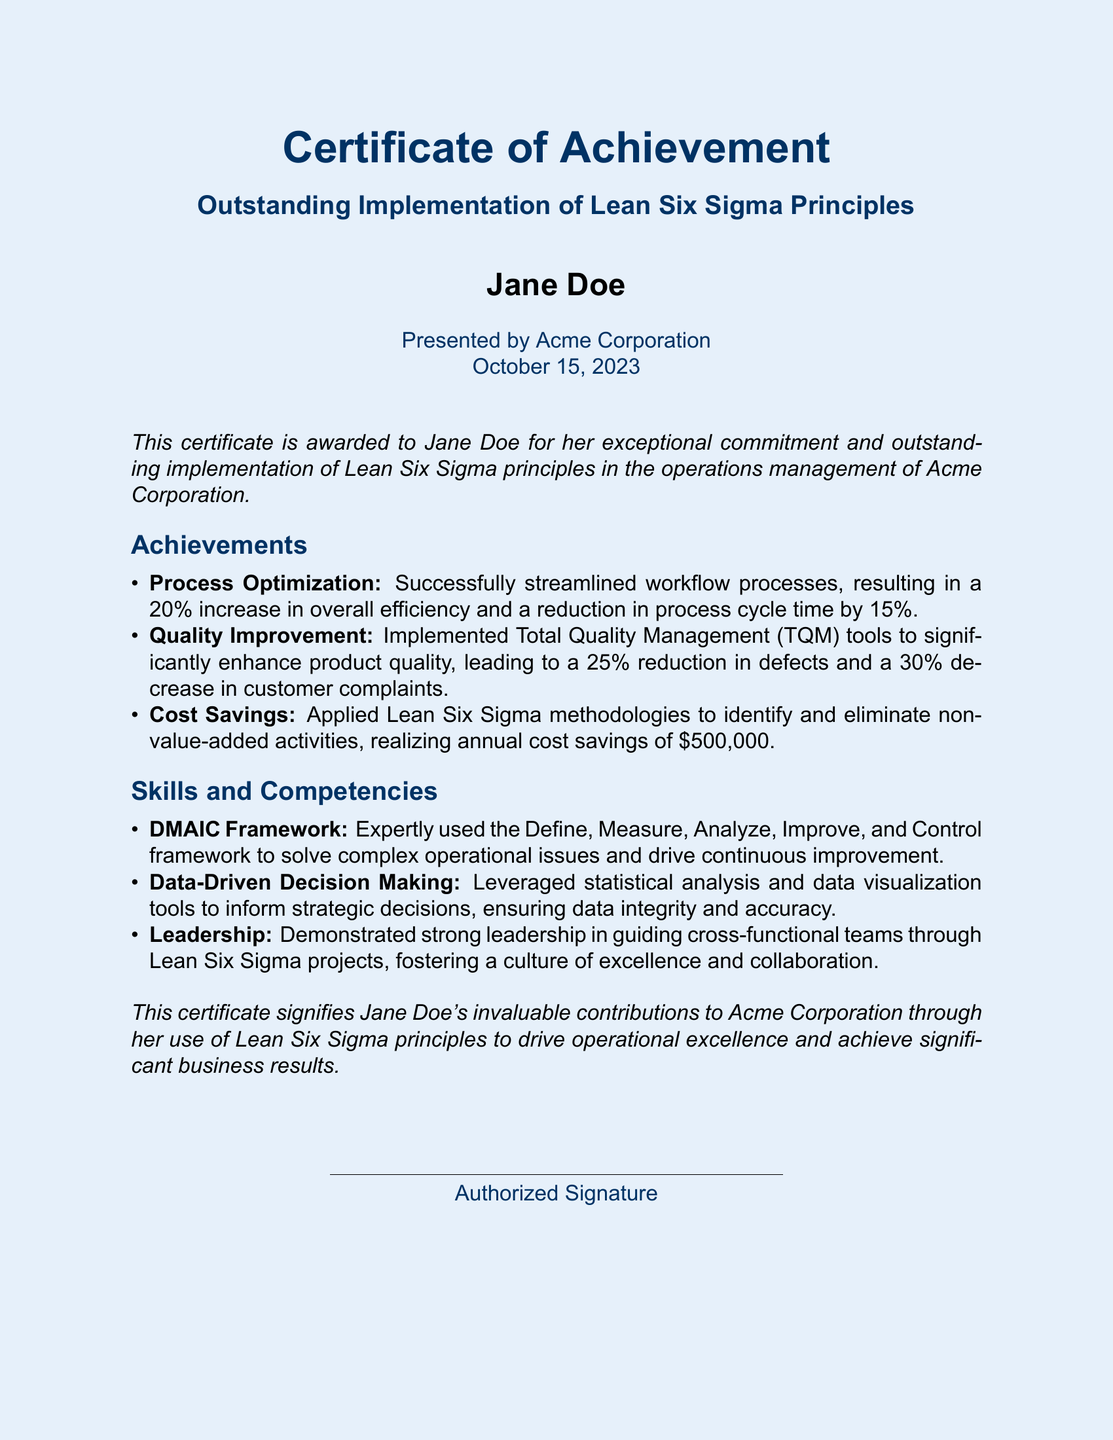What is the title of the certificate? The title of the certificate is prominently displayed in the document as "Outstanding Implementation of Lean Six Sigma Principles."
Answer: Outstanding Implementation of Lean Six Sigma Principles Who is the recipient of the certificate? The recipient's name, as noted on the certificate, is "Jane Doe."
Answer: Jane Doe What date was the certificate awarded? The date of the certificate is mentioned at the bottom, which is "October 15, 2023."
Answer: October 15, 2023 What percentage increase in efficiency was achieved? The document states that there was a "20% increase in overall efficiency."
Answer: 20% How much annual cost savings were realized? According to the achievements listed, the annual cost savings realized were "$500,000."
Answer: $500,000 What framework was expertly used for operational issues? The document highlights the "DMAIC Framework" as being expertly used to address operational issues.
Answer: DMAIC Framework How much was the reduction in defects achieved? The certificate mentions a "25% reduction in defects" in product quality.
Answer: 25% What is a key skill demonstrated by the recipient? One of the key skills mentioned is "Data-Driven Decision Making."
Answer: Data-Driven Decision Making Who presented the certificate? The certificate indicates that it was presented by "Acme Corporation."
Answer: Acme Corporation 